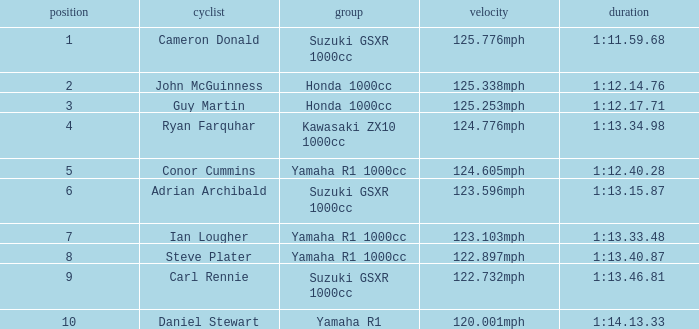What time did team kawasaki zx10 1000cc have? 1:13.34.98. 